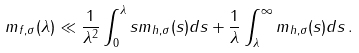Convert formula to latex. <formula><loc_0><loc_0><loc_500><loc_500>m _ { f , \sigma } ( \lambda ) \ll \frac { 1 } { \lambda ^ { 2 } } \int _ { 0 } ^ { \lambda } s m _ { h , \sigma } ( s ) d s + \frac { 1 } { \lambda } \int _ { \lambda } ^ { \infty } m _ { h , \sigma } ( s ) d s \, .</formula> 